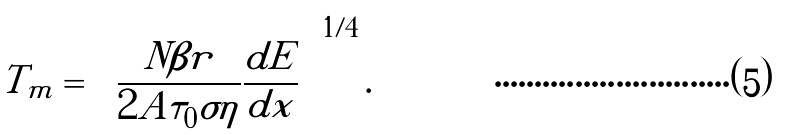Convert formula to latex. <formula><loc_0><loc_0><loc_500><loc_500>T _ { m } = \left ( \frac { N \beta r } { 2 A \tau _ { 0 } \sigma \eta } \frac { d E } { d x } \right ) ^ { 1 / 4 } .</formula> 